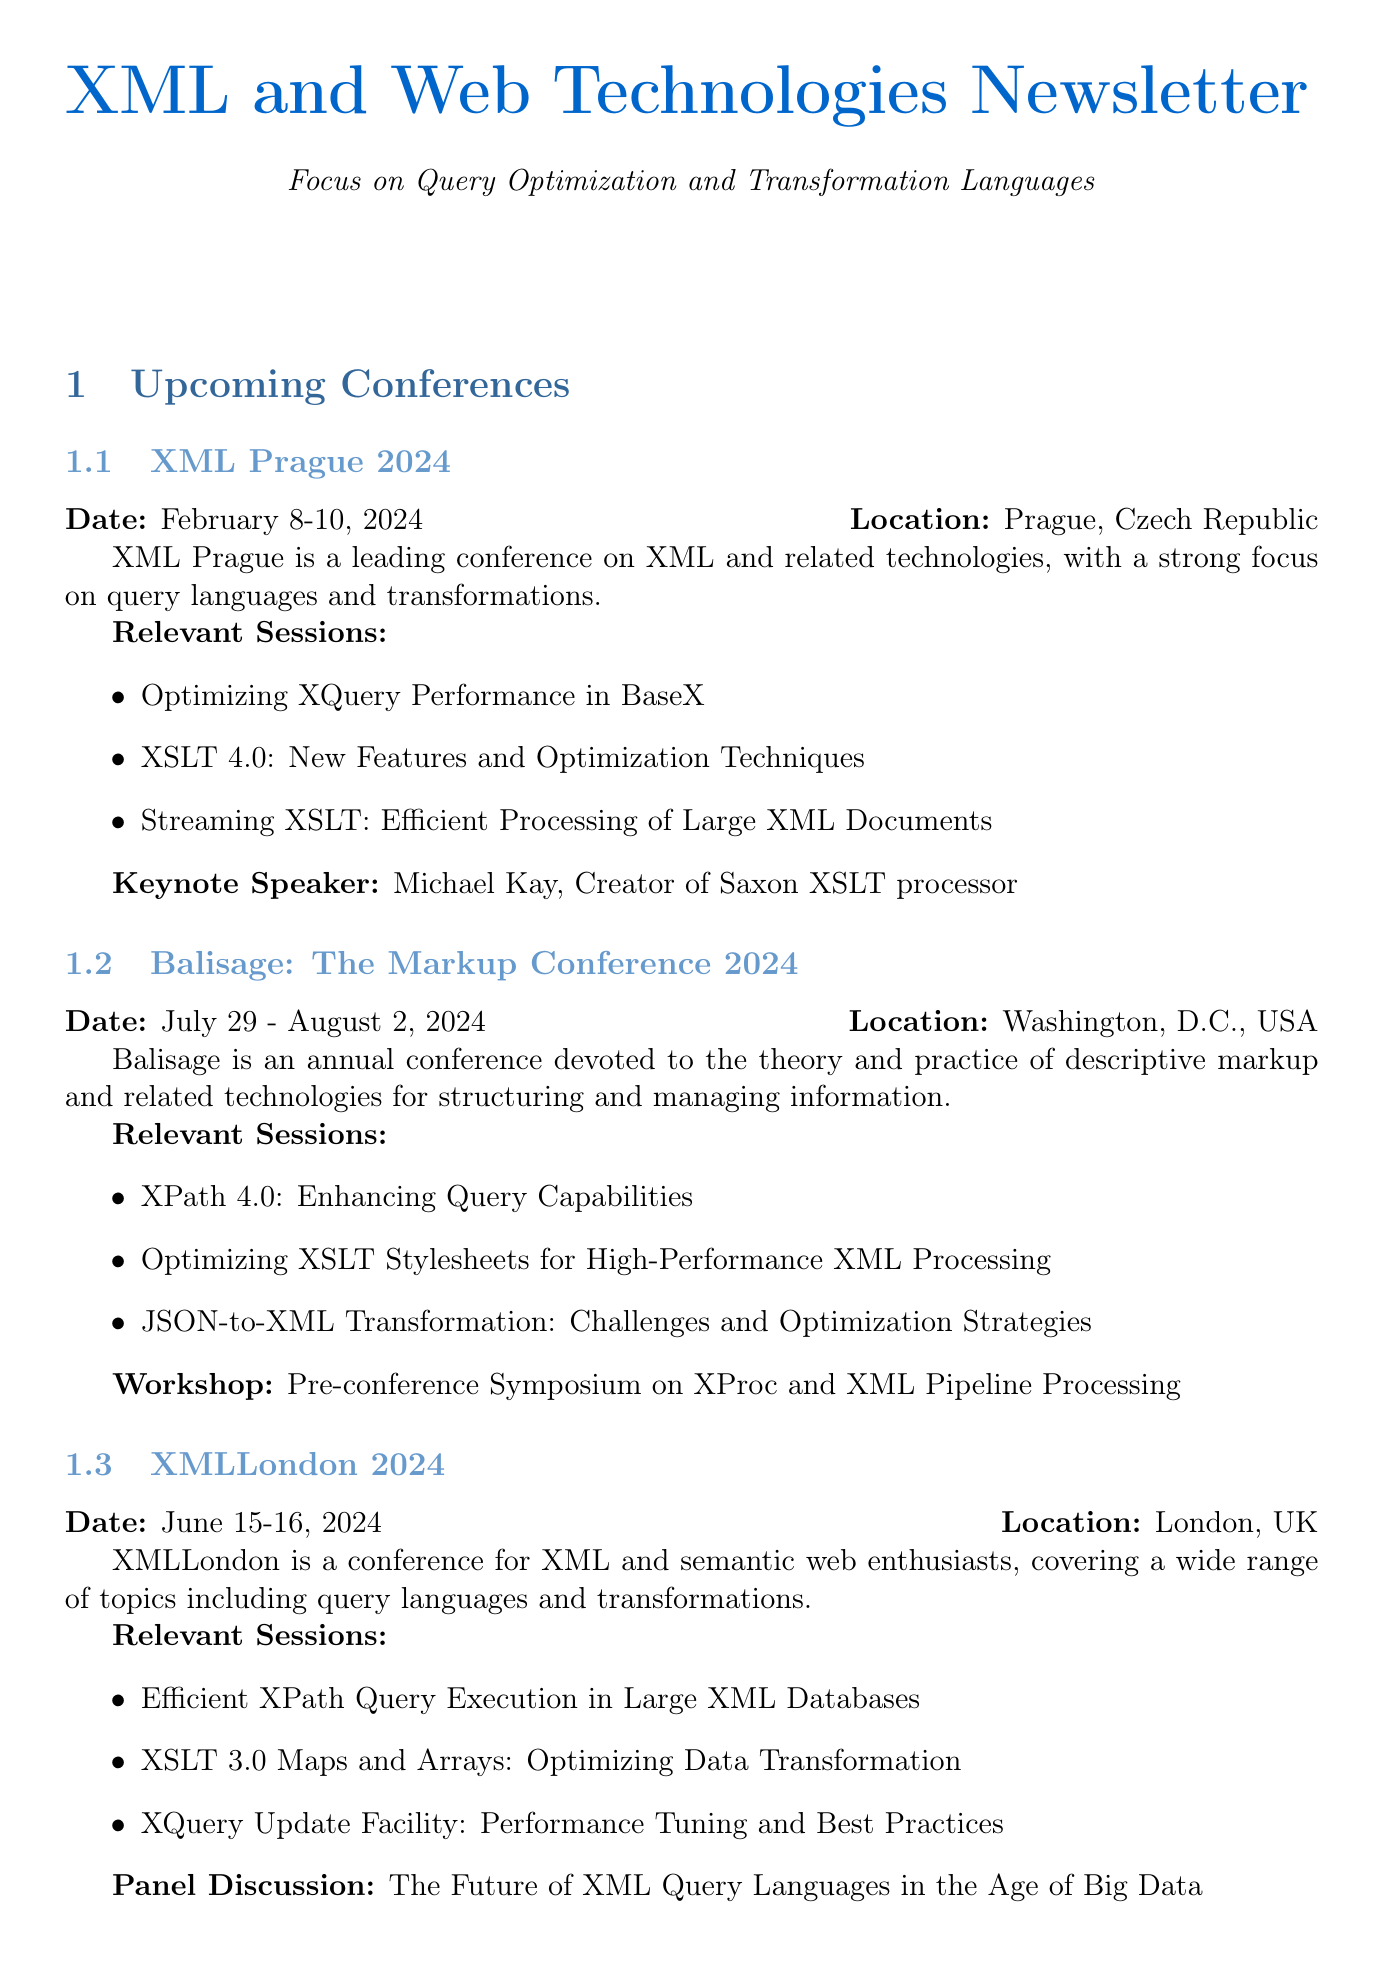What is the date of XML Prague 2024? The date is specifically listed in the document under the section "XML Prague 2024."
Answer: February 8-10, 2024 Who is the keynote speaker at XML Prague 2024? The keynote speaker is mentioned in the XML Prague section of the document.
Answer: Michael Kay What is the location of Balisage: The Markup Conference 2024? The location is provided in the Balisage section within the document.
Answer: Washington, D.C., USA Which session focuses on optimizing XSLT stylesheets? This session is listed in the Balisage section under relevant sessions.
Answer: Optimizing XSLT Stylesheets for High-Performance XML Processing What is the title of the research paper presented at ACM SIGMOD/PODS Conference 2024? The title of the research paper is found in the relevant sections of the ACM SIGMOD/PODS Conference description.
Answer: A Novel Approach to Optimizing XSLT Transformations Using Graph-based Analysis What panel discussion is scheduled at XMLLondon 2024? The panel discussion is mentioned in the XMLLondon section, indicating a thematic focus at the conference.
Answer: The Future of XML Query Languages in the Age of Big Data How many relevant sessions are listed for DocEng 2024? The total number of relevant sessions can be counted in the DocEng section of the document.
Answer: Three Which conference features a workshop on XProc and XML Pipeline Processing? The workshop is specifically mentioned in the Balisage section of the document.
Answer: Balisage: The Markup Conference 2024 What additional resource focuses on updates from the Saxon processor? This resource is detailed in the additional resources section, indicating a source of relevant information.
Answer: Saxon XSLT and XQuery Processor Blog 